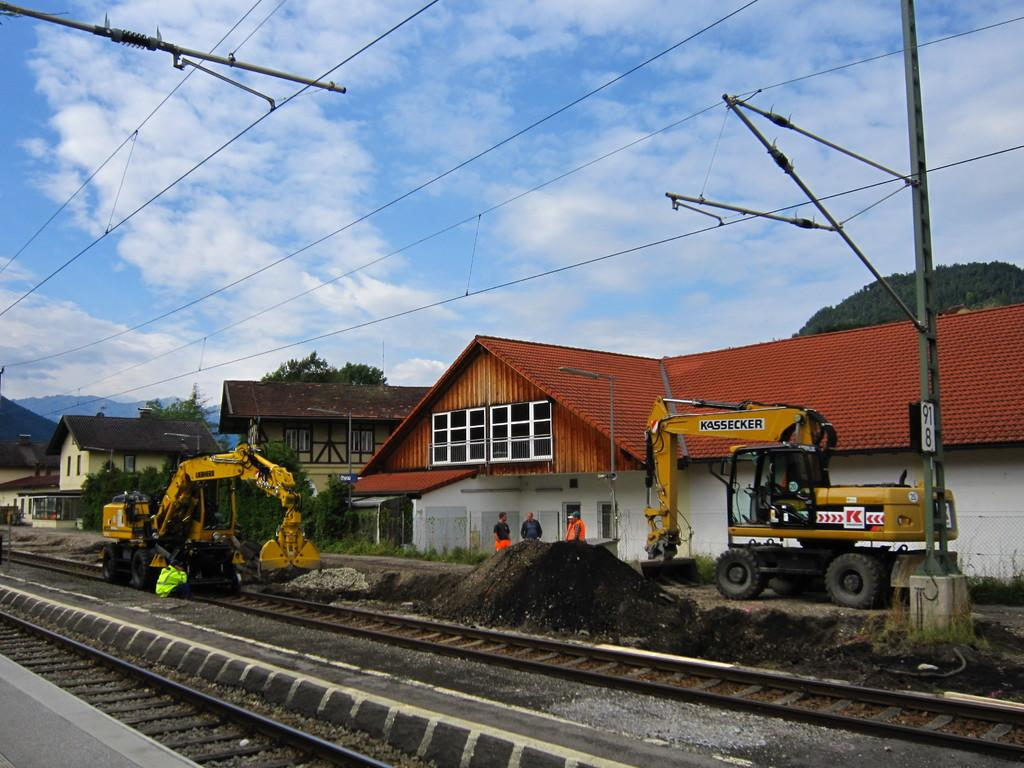What type of infrastructure can be seen in the image? There are railway tracks in the image. What construction vehicles are present in the image? There is an excavator and a bulldozer in the image. Are there any people visible in the image? Yes, there are people in the image. What structures can be seen in the background of the image? There are sheds, poles, and wires in the background of the image. What type of natural environment is visible in the background of the image? There are trees, hills, and the sky visible in the background of the image. What type of prose is being recited by the worm in the image? There is no worm present in the image, and therefore no prose being recited. What is the level of fear exhibited by the people in the image? The level of fear exhibited by the people in the image cannot be determined from the image alone. 